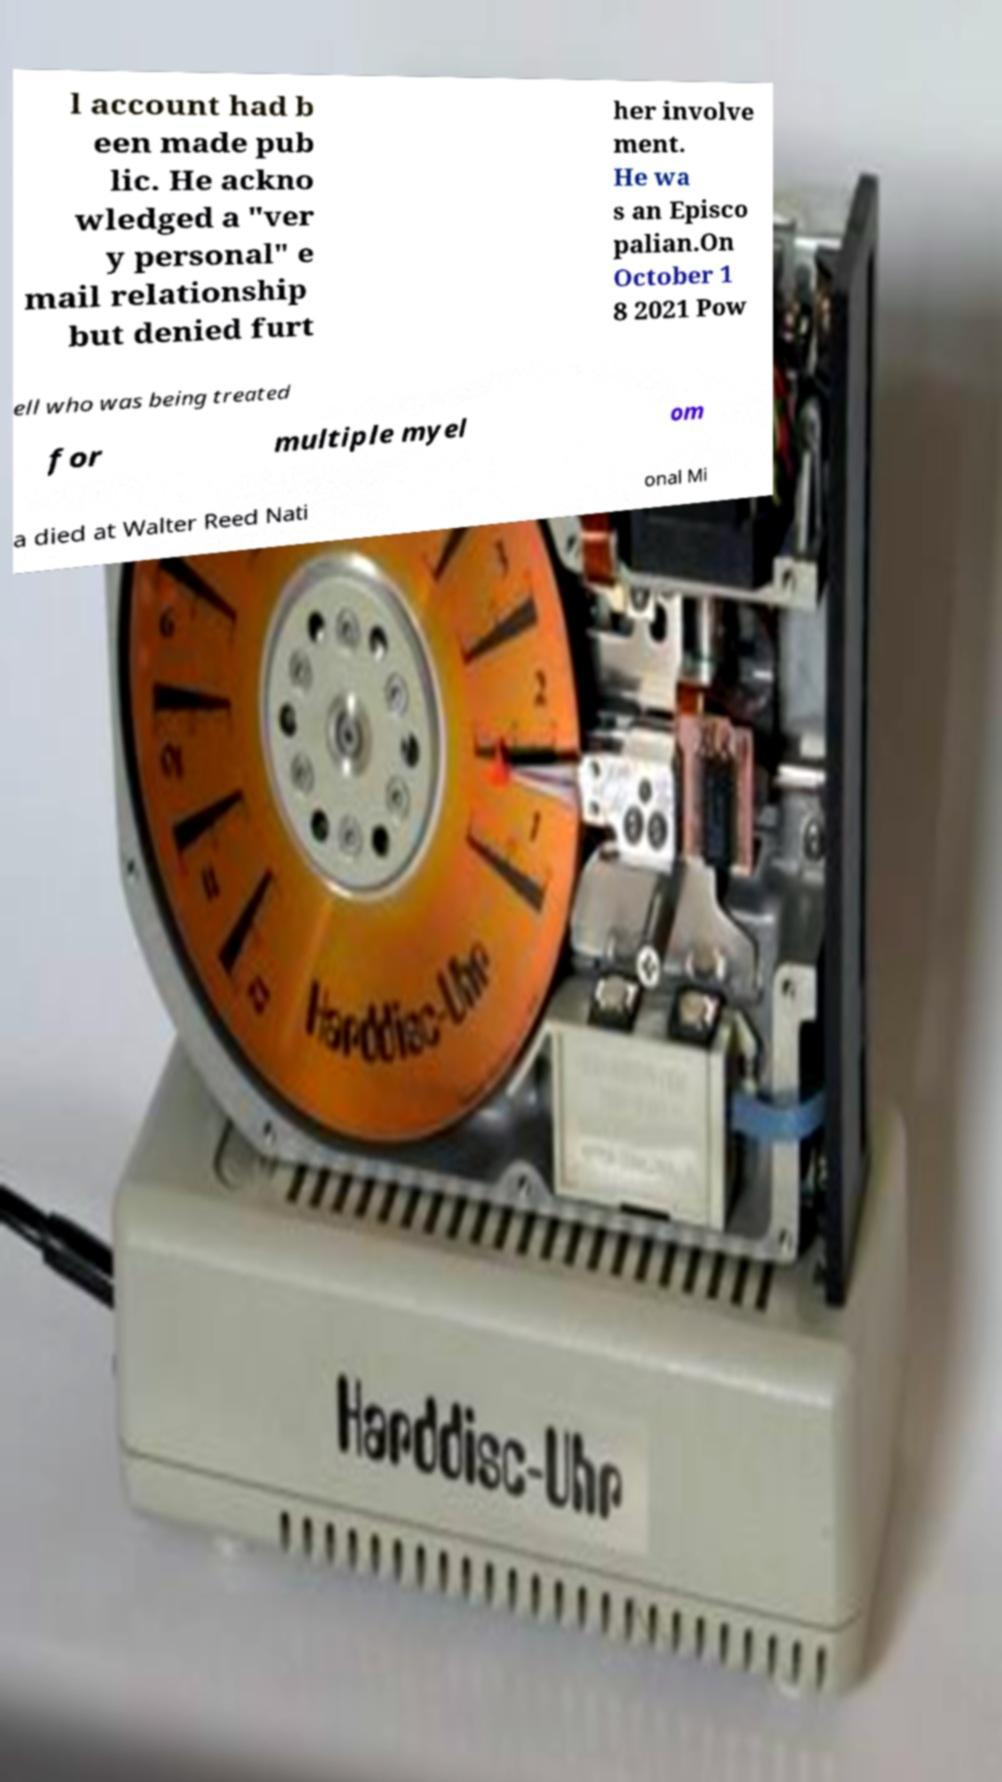Could you extract and type out the text from this image? l account had b een made pub lic. He ackno wledged a "ver y personal" e mail relationship but denied furt her involve ment. He wa s an Episco palian.On October 1 8 2021 Pow ell who was being treated for multiple myel om a died at Walter Reed Nati onal Mi 